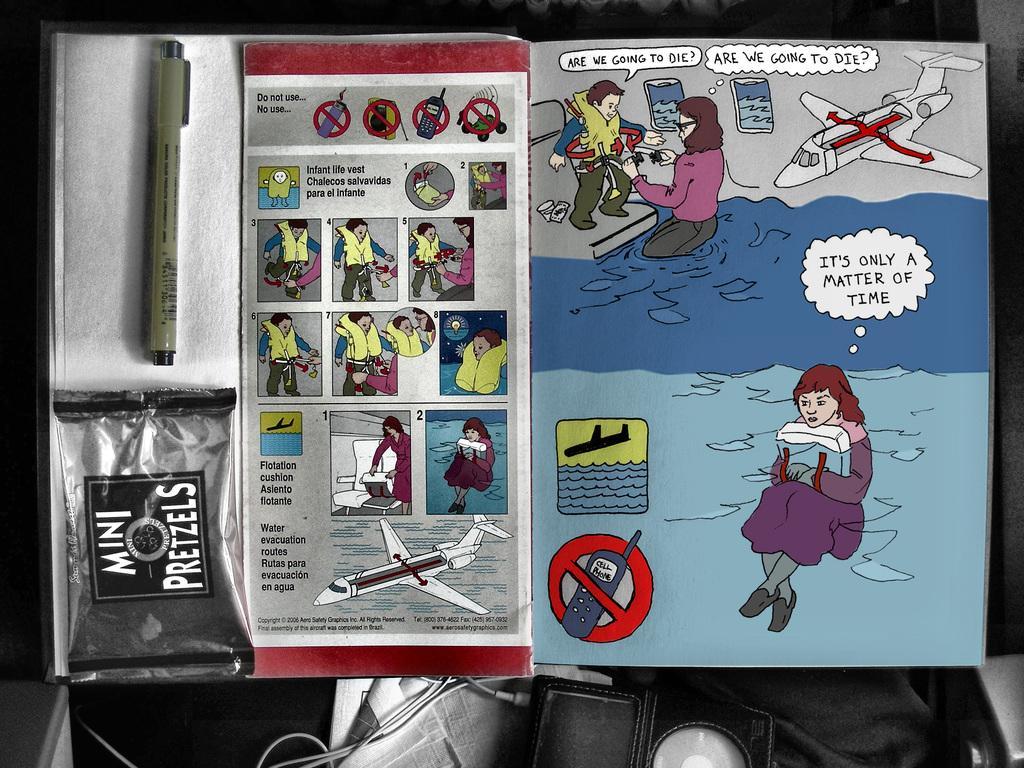Can you describe this image briefly? In this image we can see some texts, drawings, and planes on the paper and also I can see a pen. 